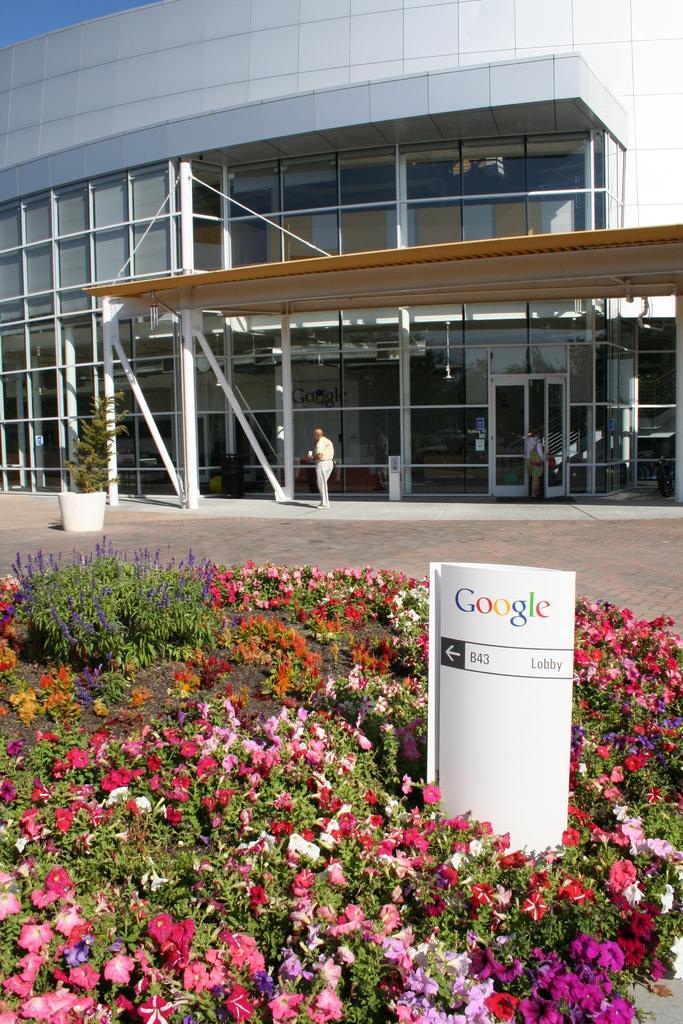Please provide a concise description of this image. In the center of the image we can see a board with some text. And we can see planets with different colored flowers. In the background, we can see the sky, one building, one pot with a plant, two persons and some objects. 